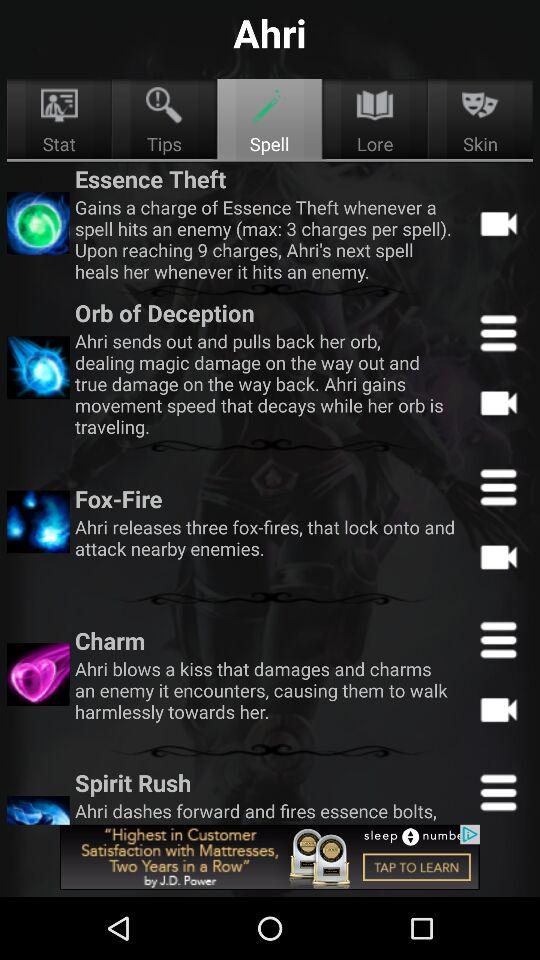How many items are there in "Lore"?
When the provided information is insufficient, respond with <no answer>. <no answer> 